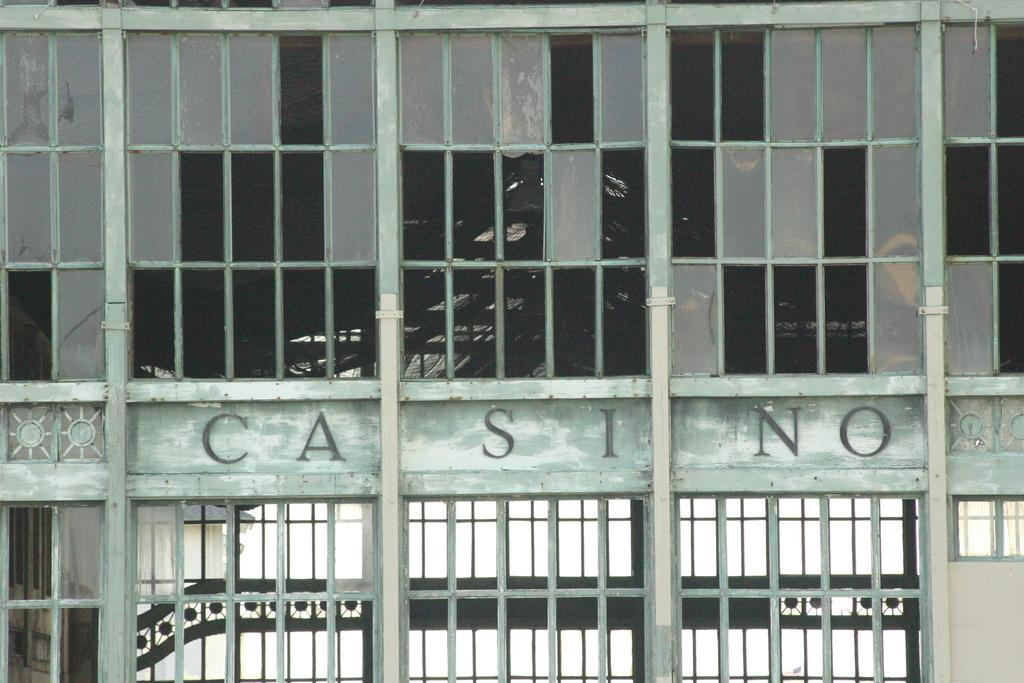What type of building is shown in the image? There is a glass building in the image. Is there any text or writing on the building? Yes, there is writing on the building. What feature of the building can be seen through the windows? There are windows visible on the building. Where is the desk and calendar located in the image? There is no desk or calendar present in the image; it only features a glass building with writing and windows. 